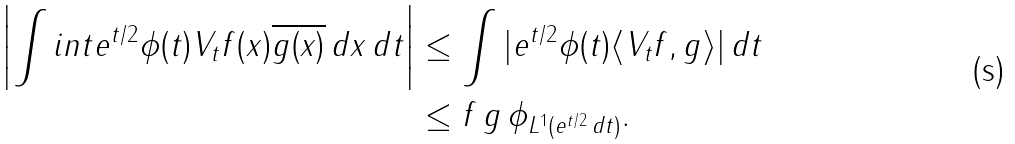<formula> <loc_0><loc_0><loc_500><loc_500>\left | \int i n t e ^ { t / 2 } \phi ( t ) V _ { t } f ( x ) \overline { g ( x ) } \, d x \, d t \right | & \leq \int | e ^ { t / 2 } \phi ( t ) \langle V _ { t } f , g \rangle | \, d t \\ & \leq \| f \| \, \| g \| \, \| \phi \| _ { L ^ { 1 } ( e ^ { t / 2 } \, d t ) } .</formula> 